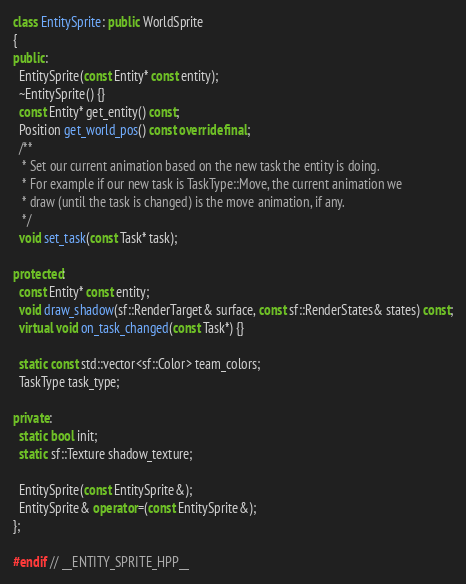<code> <loc_0><loc_0><loc_500><loc_500><_C++_>
class EntitySprite: public WorldSprite
{
public:
  EntitySprite(const Entity* const entity);
  ~EntitySprite() {}
  const Entity* get_entity() const;
  Position get_world_pos() const override final;
  /**
   * Set our current animation based on the new task the entity is doing.
   * For example if our new task is TaskType::Move, the current animation we
   * draw (until the task is changed) is the move animation, if any.
   */
  void set_task(const Task* task);

protected:
  const Entity* const entity;
  void draw_shadow(sf::RenderTarget& surface, const sf::RenderStates& states) const;
  virtual void on_task_changed(const Task*) {}

  static const std::vector<sf::Color> team_colors;
  TaskType task_type;

private:
  static bool init;
  static sf::Texture shadow_texture;

  EntitySprite(const EntitySprite&);
  EntitySprite& operator=(const EntitySprite&);
};

#endif // __ENTITY_SPRITE_HPP__
</code> 